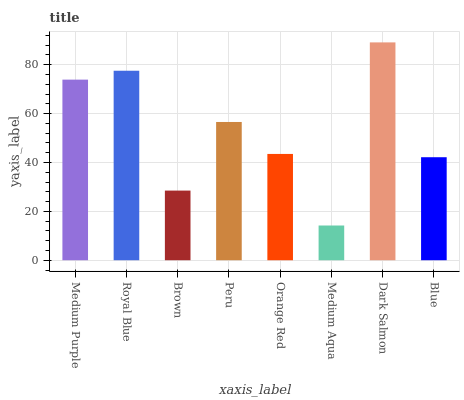Is Medium Aqua the minimum?
Answer yes or no. Yes. Is Dark Salmon the maximum?
Answer yes or no. Yes. Is Royal Blue the minimum?
Answer yes or no. No. Is Royal Blue the maximum?
Answer yes or no. No. Is Royal Blue greater than Medium Purple?
Answer yes or no. Yes. Is Medium Purple less than Royal Blue?
Answer yes or no. Yes. Is Medium Purple greater than Royal Blue?
Answer yes or no. No. Is Royal Blue less than Medium Purple?
Answer yes or no. No. Is Peru the high median?
Answer yes or no. Yes. Is Orange Red the low median?
Answer yes or no. Yes. Is Medium Purple the high median?
Answer yes or no. No. Is Peru the low median?
Answer yes or no. No. 